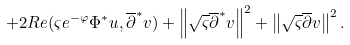Convert formula to latex. <formula><loc_0><loc_0><loc_500><loc_500>+ 2 R e ( \varsigma e ^ { - \varphi } \Phi ^ { * } u , \overline { \partial } ^ { * } v ) + \left \| \sqrt { \varsigma } \overline { \partial } ^ { * } v \right \| ^ { 2 } + \left \| \sqrt { \varsigma } \overline { \partial } v \right \| ^ { 2 } . \</formula> 